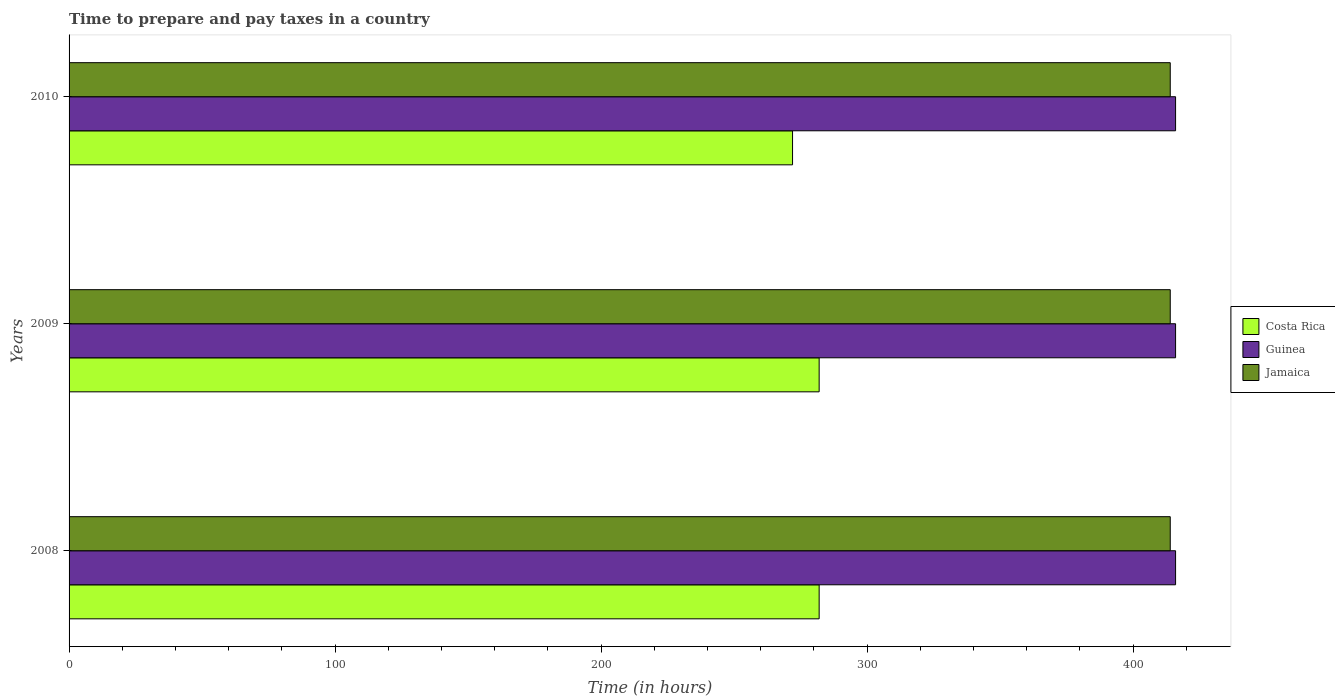How many different coloured bars are there?
Your answer should be very brief. 3. How many groups of bars are there?
Make the answer very short. 3. Are the number of bars per tick equal to the number of legend labels?
Provide a short and direct response. Yes. How many bars are there on the 1st tick from the top?
Provide a succinct answer. 3. How many bars are there on the 3rd tick from the bottom?
Ensure brevity in your answer.  3. What is the number of hours required to prepare and pay taxes in Jamaica in 2008?
Offer a terse response. 414. Across all years, what is the maximum number of hours required to prepare and pay taxes in Guinea?
Provide a succinct answer. 416. Across all years, what is the minimum number of hours required to prepare and pay taxes in Costa Rica?
Your answer should be very brief. 272. In which year was the number of hours required to prepare and pay taxes in Costa Rica minimum?
Provide a short and direct response. 2010. What is the total number of hours required to prepare and pay taxes in Jamaica in the graph?
Your answer should be compact. 1242. What is the difference between the number of hours required to prepare and pay taxes in Costa Rica in 2008 and that in 2009?
Ensure brevity in your answer.  0. What is the difference between the number of hours required to prepare and pay taxes in Jamaica in 2010 and the number of hours required to prepare and pay taxes in Costa Rica in 2009?
Your response must be concise. 132. What is the average number of hours required to prepare and pay taxes in Guinea per year?
Keep it short and to the point. 416. In the year 2010, what is the difference between the number of hours required to prepare and pay taxes in Guinea and number of hours required to prepare and pay taxes in Costa Rica?
Your answer should be very brief. 144. In how many years, is the number of hours required to prepare and pay taxes in Jamaica greater than 300 hours?
Keep it short and to the point. 3. What is the ratio of the number of hours required to prepare and pay taxes in Jamaica in 2008 to that in 2010?
Offer a terse response. 1. In how many years, is the number of hours required to prepare and pay taxes in Guinea greater than the average number of hours required to prepare and pay taxes in Guinea taken over all years?
Provide a short and direct response. 0. Is the sum of the number of hours required to prepare and pay taxes in Guinea in 2008 and 2009 greater than the maximum number of hours required to prepare and pay taxes in Jamaica across all years?
Offer a very short reply. Yes. What does the 1st bar from the bottom in 2008 represents?
Provide a short and direct response. Costa Rica. Is it the case that in every year, the sum of the number of hours required to prepare and pay taxes in Guinea and number of hours required to prepare and pay taxes in Jamaica is greater than the number of hours required to prepare and pay taxes in Costa Rica?
Give a very brief answer. Yes. Are the values on the major ticks of X-axis written in scientific E-notation?
Your response must be concise. No. Does the graph contain any zero values?
Provide a succinct answer. No. Where does the legend appear in the graph?
Provide a short and direct response. Center right. How many legend labels are there?
Make the answer very short. 3. How are the legend labels stacked?
Provide a succinct answer. Vertical. What is the title of the graph?
Ensure brevity in your answer.  Time to prepare and pay taxes in a country. What is the label or title of the X-axis?
Offer a terse response. Time (in hours). What is the label or title of the Y-axis?
Your response must be concise. Years. What is the Time (in hours) of Costa Rica in 2008?
Ensure brevity in your answer.  282. What is the Time (in hours) of Guinea in 2008?
Provide a succinct answer. 416. What is the Time (in hours) of Jamaica in 2008?
Give a very brief answer. 414. What is the Time (in hours) of Costa Rica in 2009?
Your answer should be very brief. 282. What is the Time (in hours) in Guinea in 2009?
Ensure brevity in your answer.  416. What is the Time (in hours) of Jamaica in 2009?
Provide a short and direct response. 414. What is the Time (in hours) in Costa Rica in 2010?
Ensure brevity in your answer.  272. What is the Time (in hours) of Guinea in 2010?
Give a very brief answer. 416. What is the Time (in hours) of Jamaica in 2010?
Keep it short and to the point. 414. Across all years, what is the maximum Time (in hours) in Costa Rica?
Your answer should be very brief. 282. Across all years, what is the maximum Time (in hours) of Guinea?
Provide a succinct answer. 416. Across all years, what is the maximum Time (in hours) of Jamaica?
Make the answer very short. 414. Across all years, what is the minimum Time (in hours) of Costa Rica?
Provide a succinct answer. 272. Across all years, what is the minimum Time (in hours) in Guinea?
Provide a short and direct response. 416. Across all years, what is the minimum Time (in hours) in Jamaica?
Your response must be concise. 414. What is the total Time (in hours) of Costa Rica in the graph?
Provide a succinct answer. 836. What is the total Time (in hours) of Guinea in the graph?
Provide a succinct answer. 1248. What is the total Time (in hours) of Jamaica in the graph?
Provide a succinct answer. 1242. What is the difference between the Time (in hours) in Costa Rica in 2008 and that in 2009?
Your answer should be compact. 0. What is the difference between the Time (in hours) of Guinea in 2008 and that in 2009?
Offer a very short reply. 0. What is the difference between the Time (in hours) of Guinea in 2008 and that in 2010?
Give a very brief answer. 0. What is the difference between the Time (in hours) in Jamaica in 2008 and that in 2010?
Make the answer very short. 0. What is the difference between the Time (in hours) of Costa Rica in 2008 and the Time (in hours) of Guinea in 2009?
Offer a very short reply. -134. What is the difference between the Time (in hours) of Costa Rica in 2008 and the Time (in hours) of Jamaica in 2009?
Provide a succinct answer. -132. What is the difference between the Time (in hours) of Costa Rica in 2008 and the Time (in hours) of Guinea in 2010?
Offer a terse response. -134. What is the difference between the Time (in hours) in Costa Rica in 2008 and the Time (in hours) in Jamaica in 2010?
Provide a short and direct response. -132. What is the difference between the Time (in hours) of Guinea in 2008 and the Time (in hours) of Jamaica in 2010?
Offer a terse response. 2. What is the difference between the Time (in hours) of Costa Rica in 2009 and the Time (in hours) of Guinea in 2010?
Provide a short and direct response. -134. What is the difference between the Time (in hours) in Costa Rica in 2009 and the Time (in hours) in Jamaica in 2010?
Give a very brief answer. -132. What is the difference between the Time (in hours) in Guinea in 2009 and the Time (in hours) in Jamaica in 2010?
Make the answer very short. 2. What is the average Time (in hours) in Costa Rica per year?
Offer a terse response. 278.67. What is the average Time (in hours) of Guinea per year?
Keep it short and to the point. 416. What is the average Time (in hours) of Jamaica per year?
Provide a succinct answer. 414. In the year 2008, what is the difference between the Time (in hours) in Costa Rica and Time (in hours) in Guinea?
Offer a terse response. -134. In the year 2008, what is the difference between the Time (in hours) of Costa Rica and Time (in hours) of Jamaica?
Make the answer very short. -132. In the year 2009, what is the difference between the Time (in hours) in Costa Rica and Time (in hours) in Guinea?
Your answer should be compact. -134. In the year 2009, what is the difference between the Time (in hours) of Costa Rica and Time (in hours) of Jamaica?
Your answer should be very brief. -132. In the year 2009, what is the difference between the Time (in hours) of Guinea and Time (in hours) of Jamaica?
Keep it short and to the point. 2. In the year 2010, what is the difference between the Time (in hours) in Costa Rica and Time (in hours) in Guinea?
Provide a succinct answer. -144. In the year 2010, what is the difference between the Time (in hours) of Costa Rica and Time (in hours) of Jamaica?
Provide a short and direct response. -142. In the year 2010, what is the difference between the Time (in hours) in Guinea and Time (in hours) in Jamaica?
Your answer should be compact. 2. What is the ratio of the Time (in hours) of Guinea in 2008 to that in 2009?
Provide a succinct answer. 1. What is the ratio of the Time (in hours) in Costa Rica in 2008 to that in 2010?
Your answer should be very brief. 1.04. What is the ratio of the Time (in hours) of Costa Rica in 2009 to that in 2010?
Offer a very short reply. 1.04. What is the ratio of the Time (in hours) in Guinea in 2009 to that in 2010?
Give a very brief answer. 1. What is the ratio of the Time (in hours) of Jamaica in 2009 to that in 2010?
Give a very brief answer. 1. What is the difference between the highest and the second highest Time (in hours) in Costa Rica?
Your answer should be compact. 0. What is the difference between the highest and the second highest Time (in hours) in Guinea?
Keep it short and to the point. 0. What is the difference between the highest and the lowest Time (in hours) in Guinea?
Keep it short and to the point. 0. 